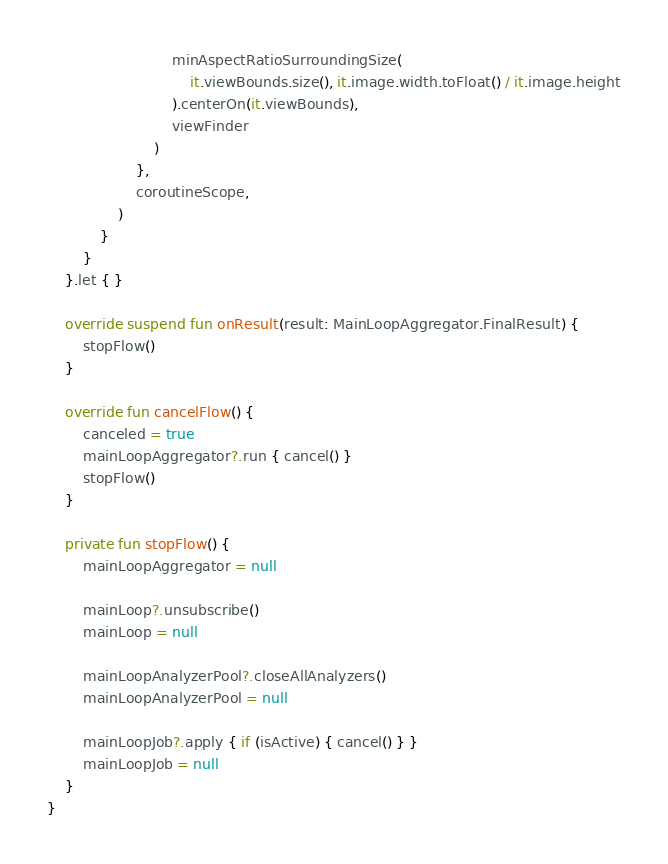Convert code to text. <code><loc_0><loc_0><loc_500><loc_500><_Kotlin_>                            minAspectRatioSurroundingSize(
                                it.viewBounds.size(), it.image.width.toFloat() / it.image.height
                            ).centerOn(it.viewBounds),
                            viewFinder
                        )
                    },
                    coroutineScope,
                )
            }
        }
    }.let { }

    override suspend fun onResult(result: MainLoopAggregator.FinalResult) {
        stopFlow()
    }

    override fun cancelFlow() {
        canceled = true
        mainLoopAggregator?.run { cancel() }
        stopFlow()
    }

    private fun stopFlow() {
        mainLoopAggregator = null

        mainLoop?.unsubscribe()
        mainLoop = null

        mainLoopAnalyzerPool?.closeAllAnalyzers()
        mainLoopAnalyzerPool = null

        mainLoopJob?.apply { if (isActive) { cancel() } }
        mainLoopJob = null
    }
}
</code> 